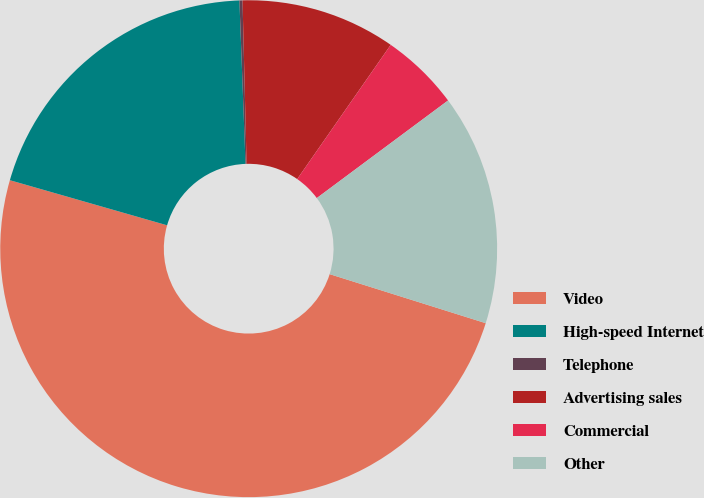Convert chart to OTSL. <chart><loc_0><loc_0><loc_500><loc_500><pie_chart><fcel>Video<fcel>High-speed Internet<fcel>Telephone<fcel>Advertising sales<fcel>Commercial<fcel>Other<nl><fcel>49.6%<fcel>19.96%<fcel>0.2%<fcel>10.08%<fcel>5.14%<fcel>15.02%<nl></chart> 